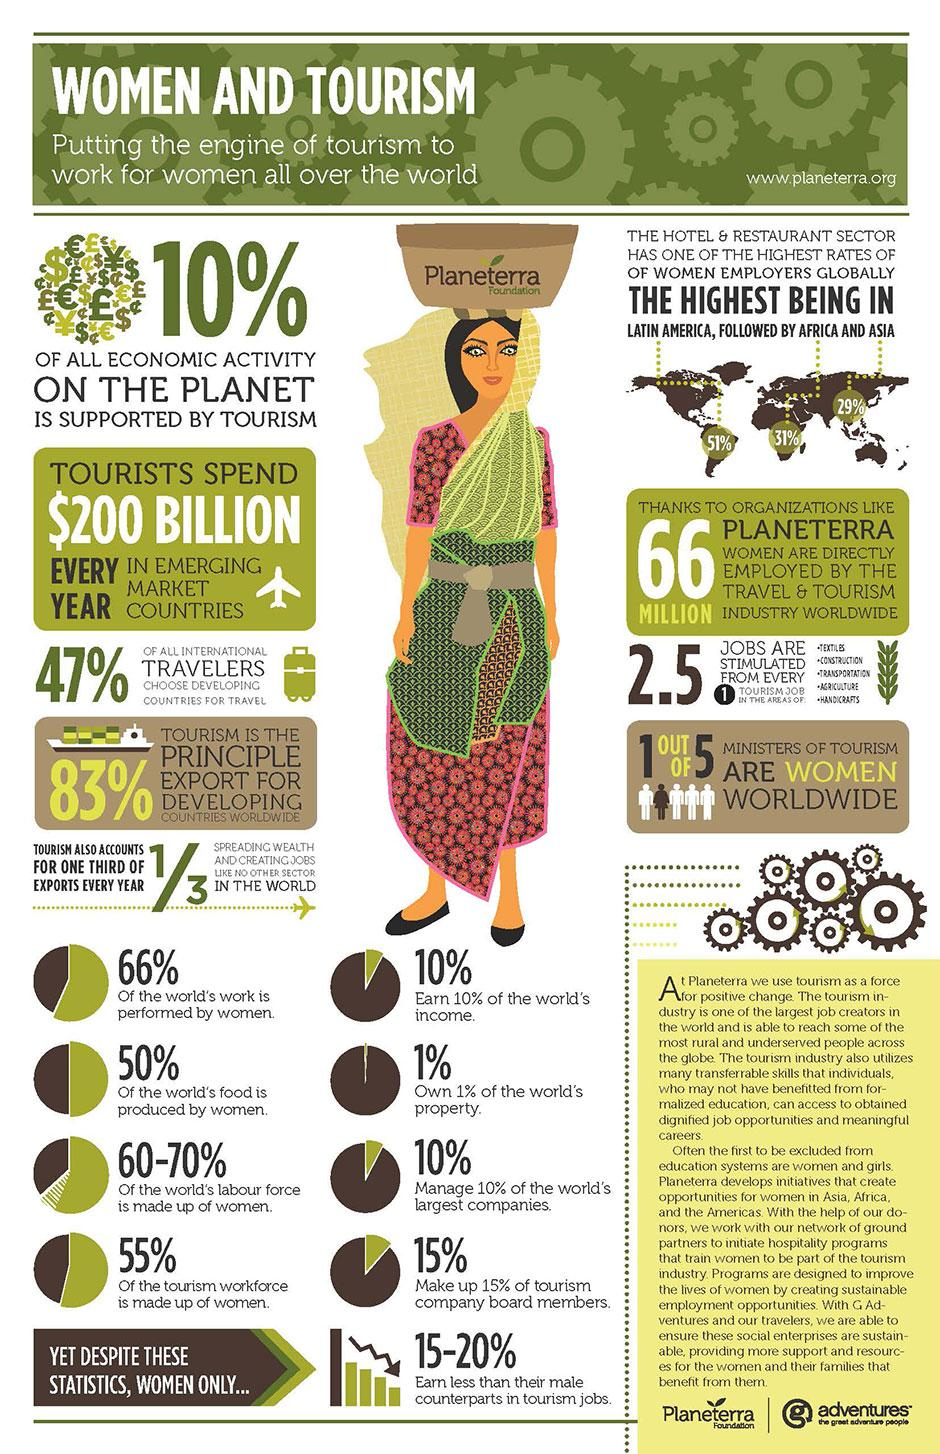Indicate a few pertinent items in this graphic. It is estimated that 45% of the tourism workforce is not made up of women. According to recent estimates, approximately 34% of the world's work is not performed by women. Out of the total number of ministers of tourism worldwide, 4 of them are not women. According to a recent study, women account for half of the world's food production, indicating that they play a significant role in ensuring global food security. According to employer ratings in Africa, women represent 31% of the workforce. 